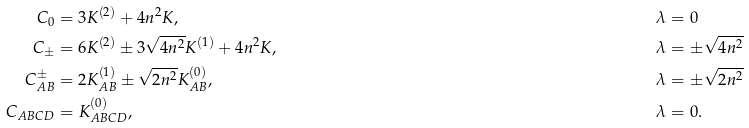<formula> <loc_0><loc_0><loc_500><loc_500>C _ { 0 } & = 3 K ^ { ( 2 ) } + 4 n ^ { 2 } K , & \lambda & = 0 \\ C _ { \pm } & = 6 K ^ { ( 2 ) } \pm 3 \sqrt { 4 n ^ { 2 } } K ^ { ( 1 ) } + 4 n ^ { 2 } K , & \lambda & = \pm \sqrt { 4 n ^ { 2 } } \\ C _ { A B } ^ { \pm } & = 2 K _ { A B } ^ { ( 1 ) } \pm \sqrt { 2 n ^ { 2 } } K _ { A B } ^ { ( 0 ) } , & \lambda & = \pm \sqrt { 2 n ^ { 2 } } \\ C _ { A B C D } & = K _ { A B C D } ^ { ( 0 ) } , & \lambda & = 0 .</formula> 